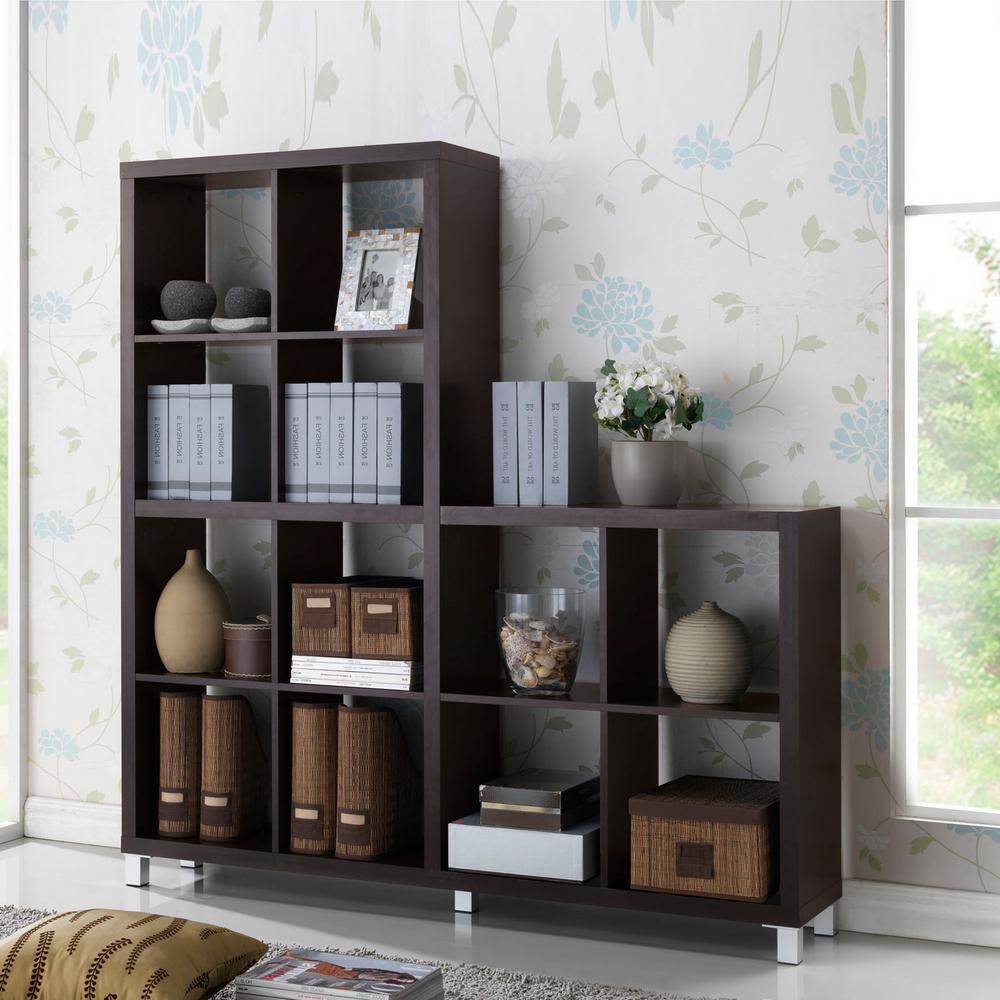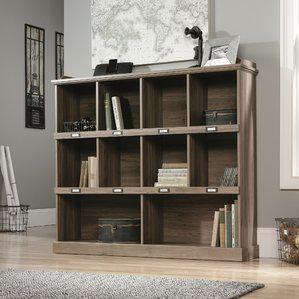The first image is the image on the left, the second image is the image on the right. Evaluate the accuracy of this statement regarding the images: "There is a pot of plant with white flowers on top of a shelf.". Is it true? Answer yes or no. Yes. 